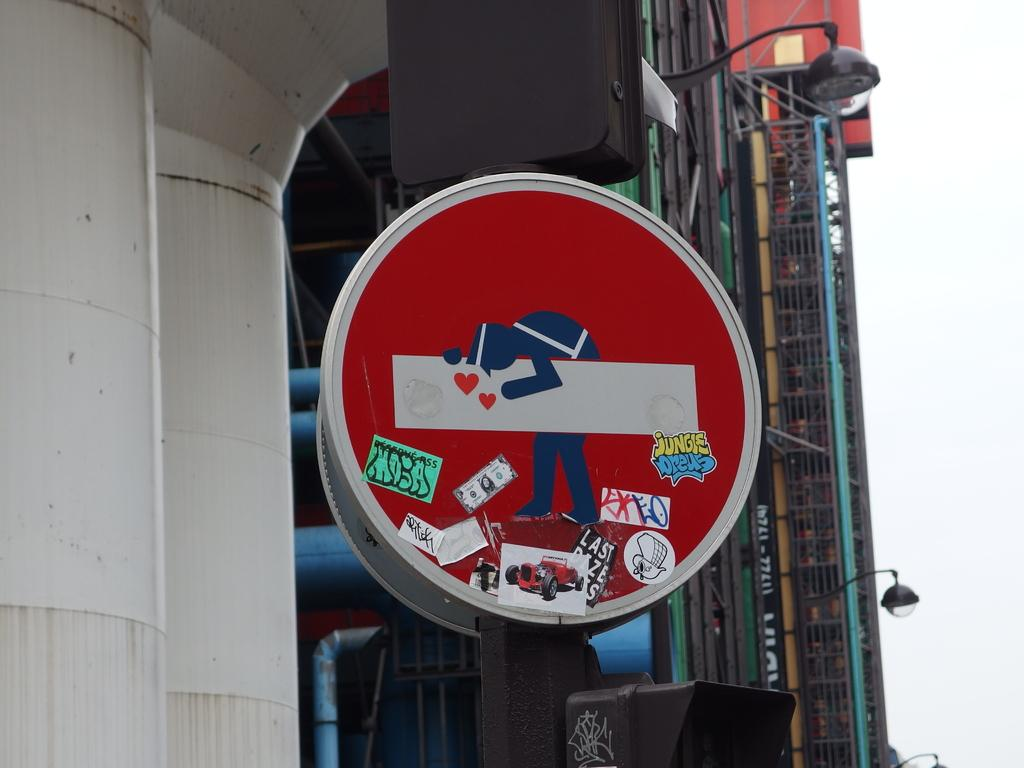<image>
Share a concise interpretation of the image provided. A red sign has stickers and graffiti on it that says Jungle. 